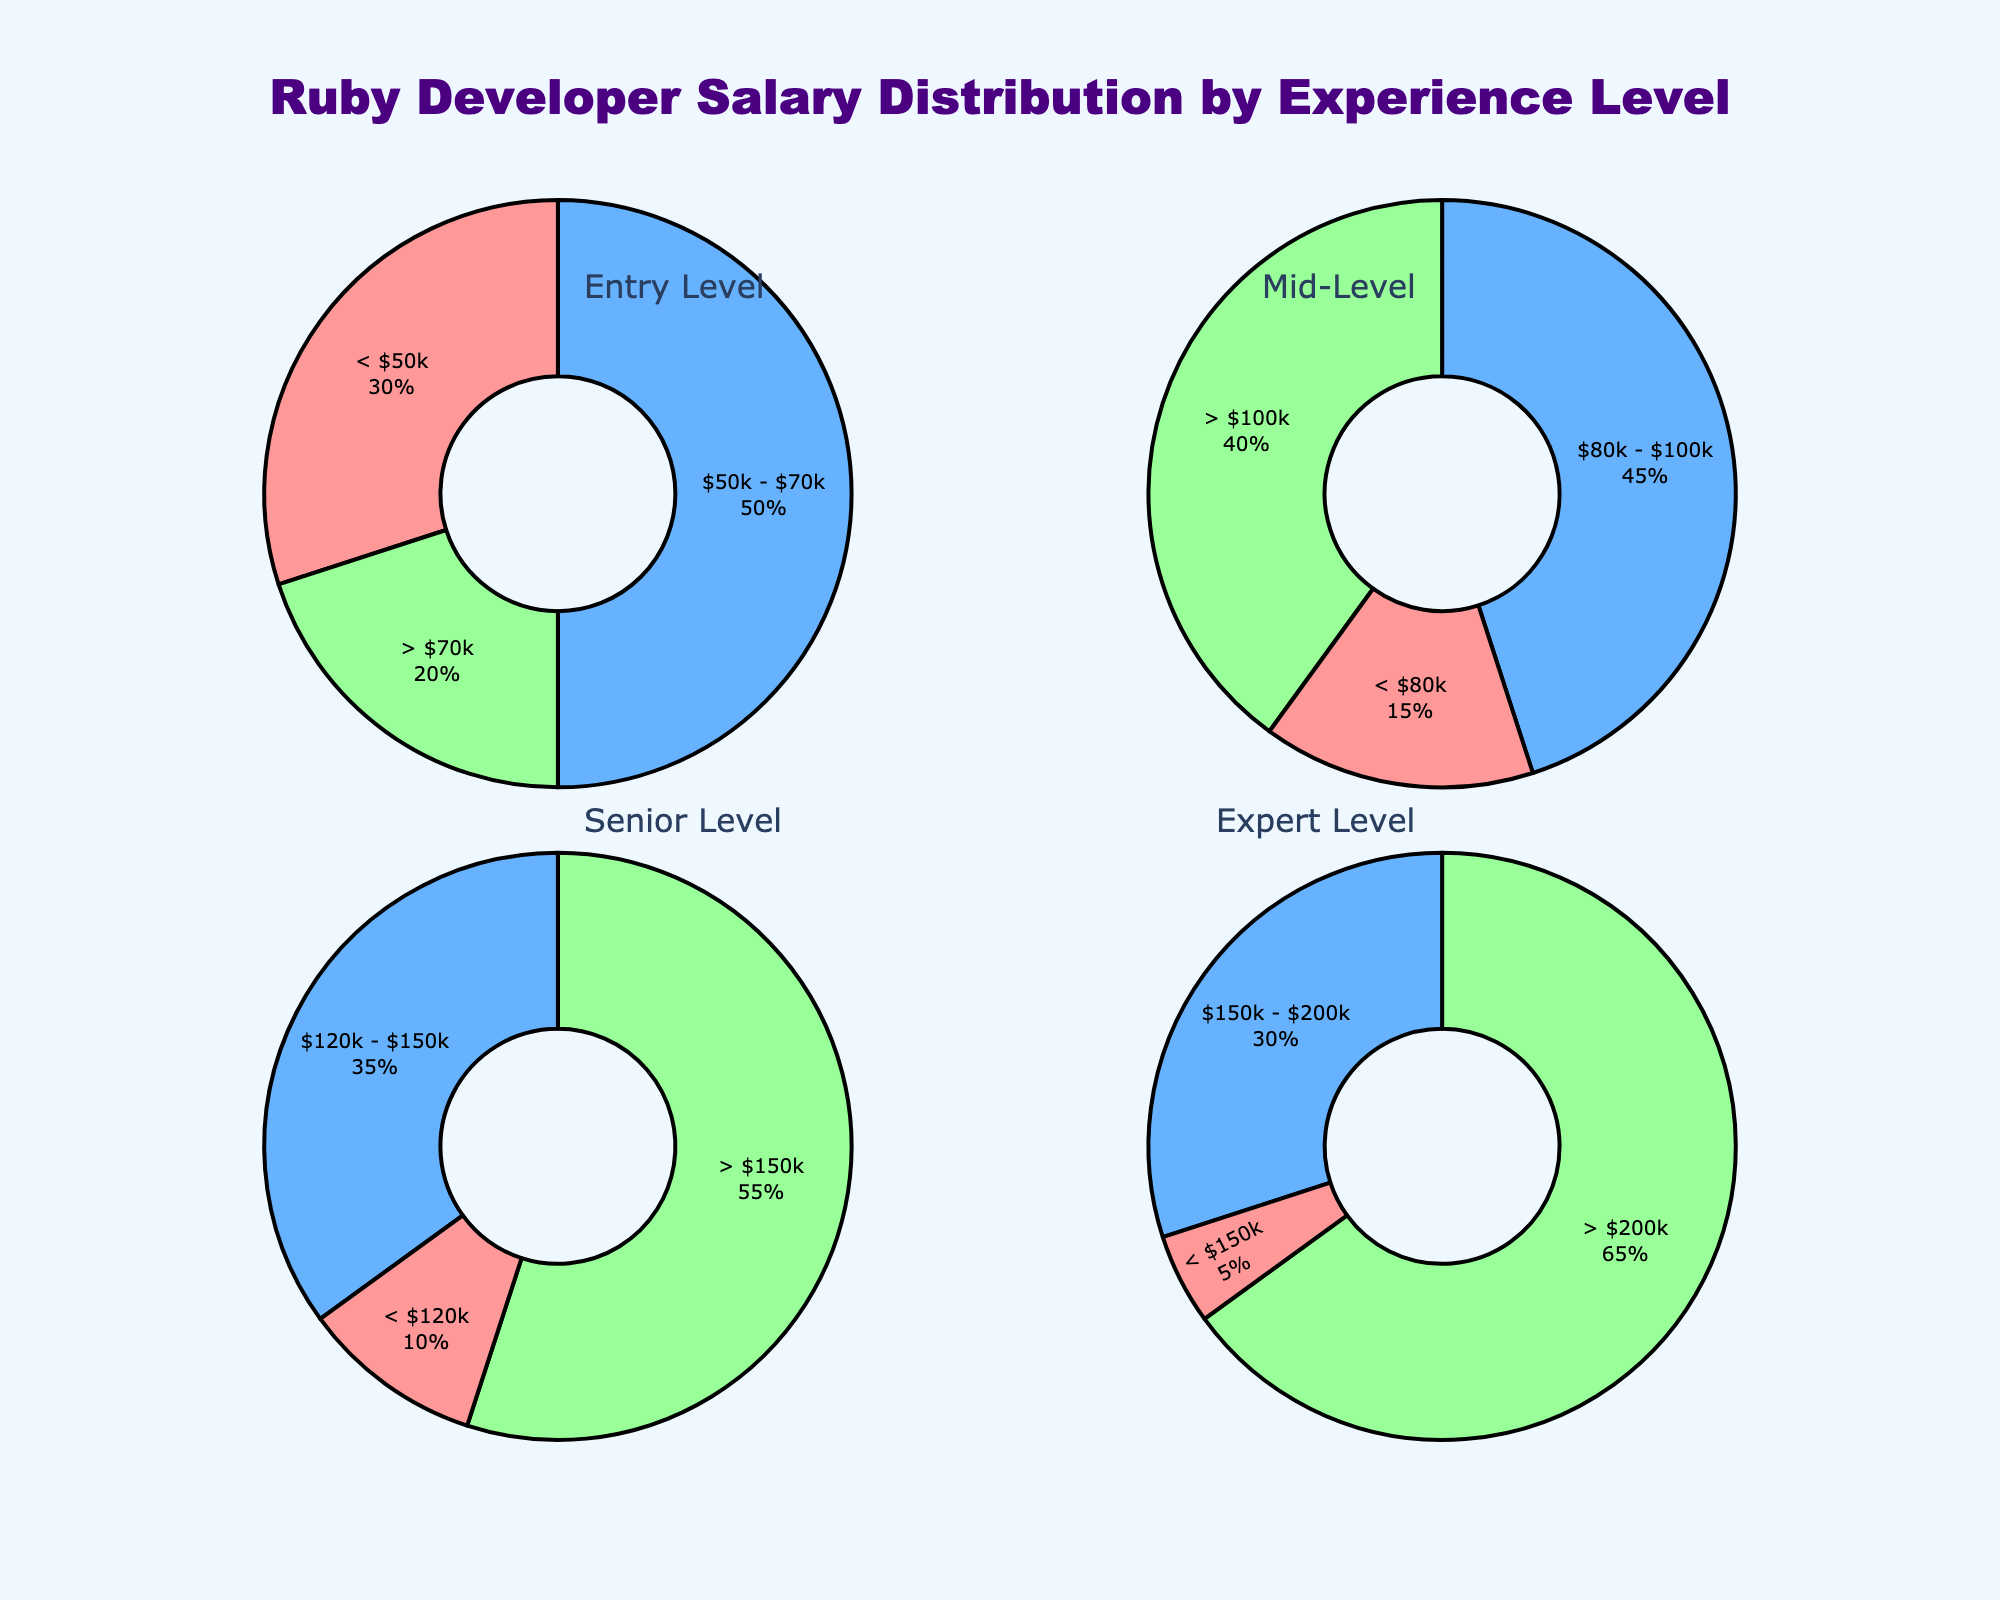What are the title and overall theme of the figure? The title of the figure is "Ruby Developer Salary Distribution by Experience Level." The overall theme is the distribution of salaries among Ruby developers at different experience levels.
Answer: Ruby Developer Salary Distribution by Experience Level What percentage of Entry-Level developers earn between $50k and $70k? To find this, locate the pie chart for Entry Level experience and identify the segment labeled "$50k - $70k." The percentage is shown directly on the label within the pie chart.
Answer: 50% Which experience level has the highest proportion of developers earning more than $200k? Check each pie chart for the ">$200k" segment and compare the values. The Expert Level pie chart shows 65%, which is the highest.
Answer: Expert Level Compare the proportion of Senior Level developers earning less than $120k to Expert Level developers earning less than $150k. Which is higher? First, find the segment for "< $120k" in the Senior Level pie chart, which is 10%. Then, find the segment for "< $150k" in the Expert Level pie chart, which is 5%.
Answer: Senior Level What is the total percentage of Mid-Level developers earning above $80k? To find the total, sum the percentages of the segments above $80k: "$80k - $100k" (45%) and "> $100k" (40%). The total is 45% + 40%.
Answer: 85% How many different colors are used in the pie charts? Observe the different colors used in any of the pie charts. The colors are pink, blue, and green.
Answer: 3 Which salary range has the lowest percentage for Entry-Level developers? Look at the Entry-Level pie chart and identify the segment with the lowest percentage. The segment labeled "> $70k" has 20%, which is the lowest percentage.
Answer: > $70k For the Expert-Level developers, what is the combined percentage of those earning between $150k and $200k, and those earning more than $200k? Sum the percentages of the segments "$150k - $200k" (30%) and "> $200k" (65%). The total is 30% + 65%.
Answer: 95% What is the largest salary range (> $150k) for Mid-Level developers? Identify the segment in the Mid-Level pie chart labeled "> $100k"; it shows the highest percentage among the other ranges.
Answer: > $100k 